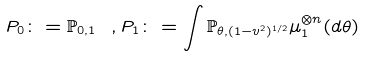<formula> <loc_0><loc_0><loc_500><loc_500>P _ { 0 } \colon = \mathbb { P } _ { 0 , 1 } \ , P _ { 1 } \colon = \int \mathbb { P } _ { \theta , ( 1 - v ^ { 2 } ) ^ { 1 / 2 } } \mu _ { 1 } ^ { \otimes n } ( d \theta )</formula> 